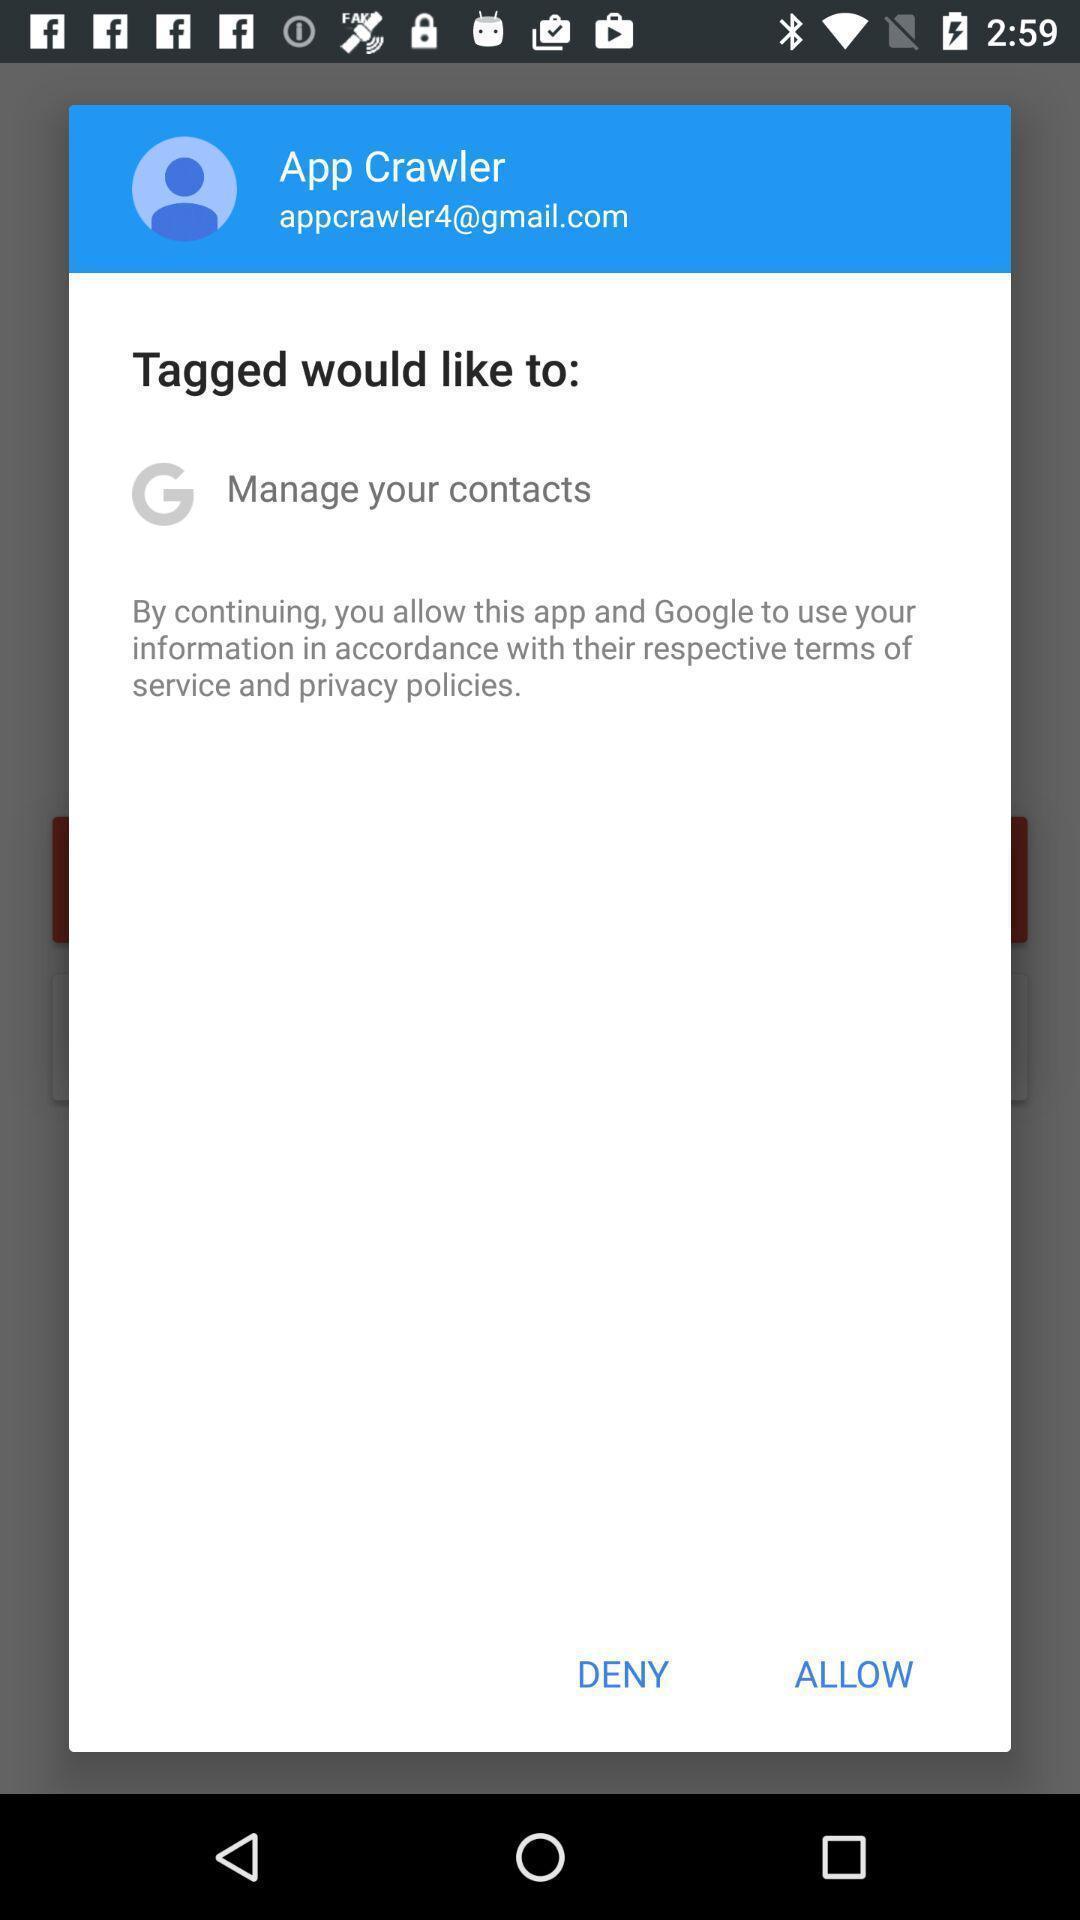What is the overall content of this screenshot? Pop-up showing option like deny allow option. 